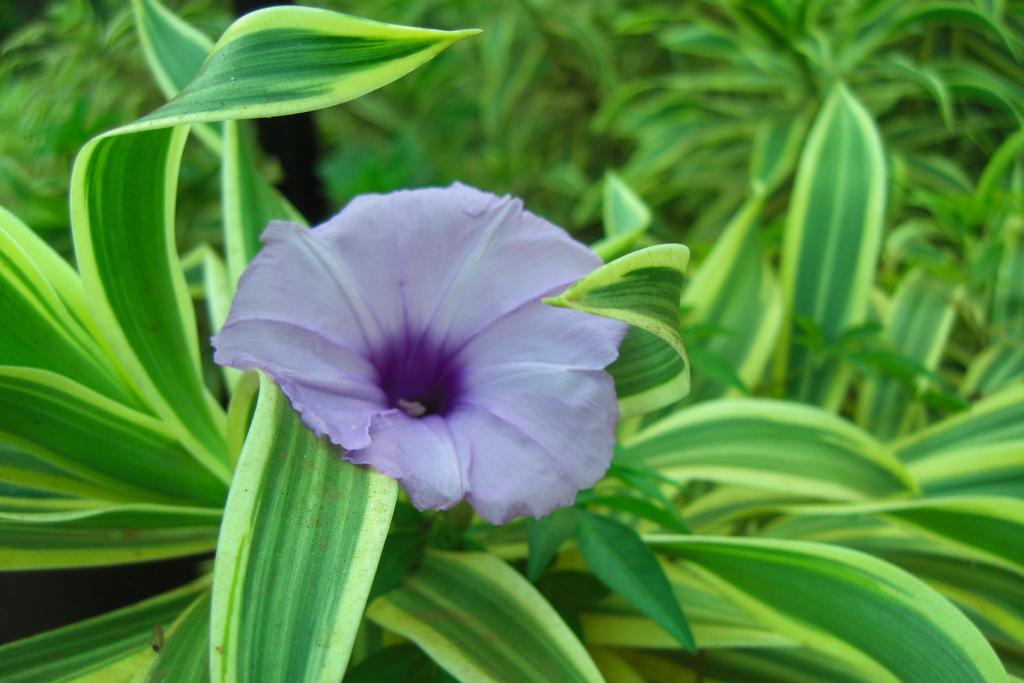Can you describe this image briefly? We can see flower and green leaves. 